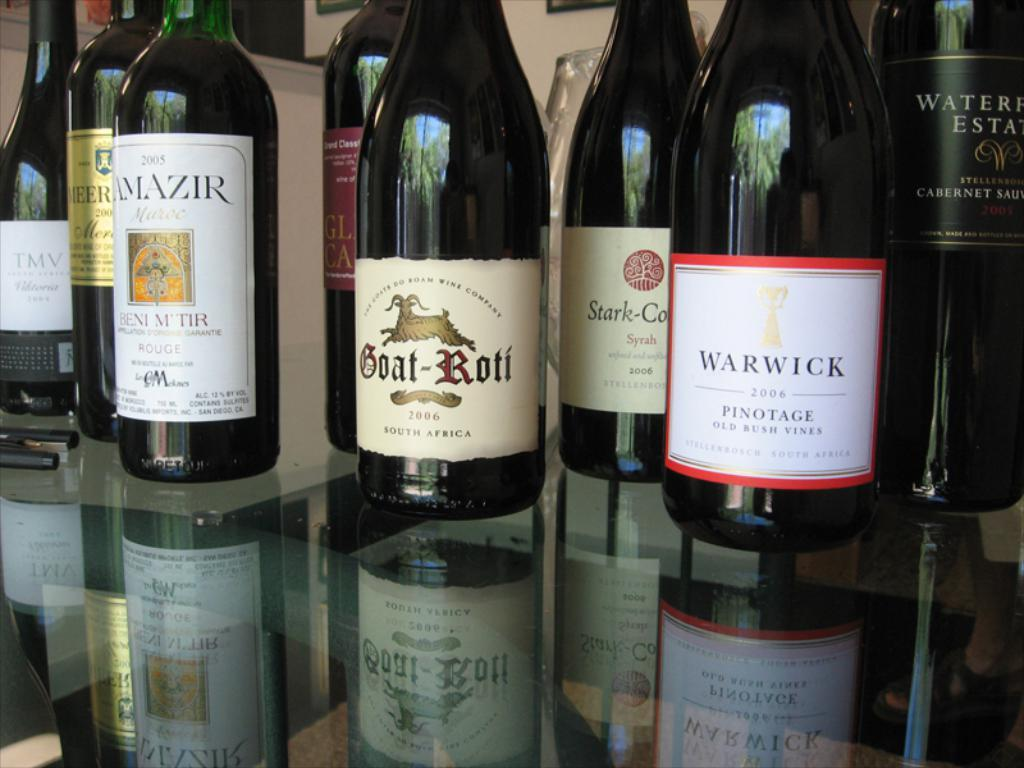Provide a one-sentence caption for the provided image. A shelf with wine bottles on it including one called Goat Roti. 